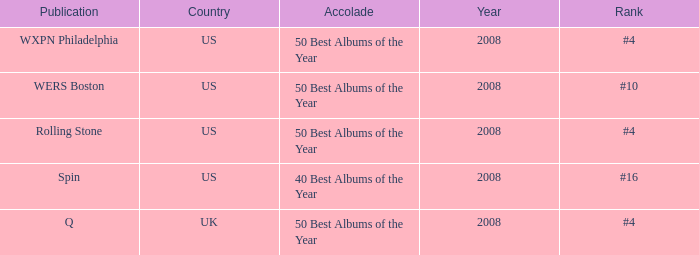Which rank's country is the US when the accolade is 40 best albums of the year? #16. 